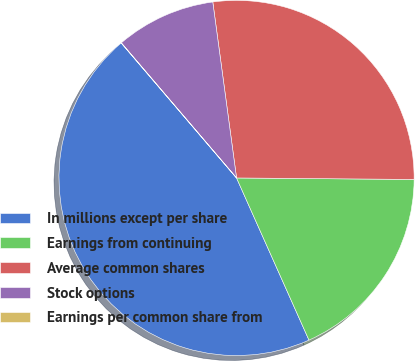Convert chart to OTSL. <chart><loc_0><loc_0><loc_500><loc_500><pie_chart><fcel>In millions except per share<fcel>Earnings from continuing<fcel>Average common shares<fcel>Stock options<fcel>Earnings per common share from<nl><fcel>45.43%<fcel>18.18%<fcel>27.27%<fcel>9.1%<fcel>0.02%<nl></chart> 